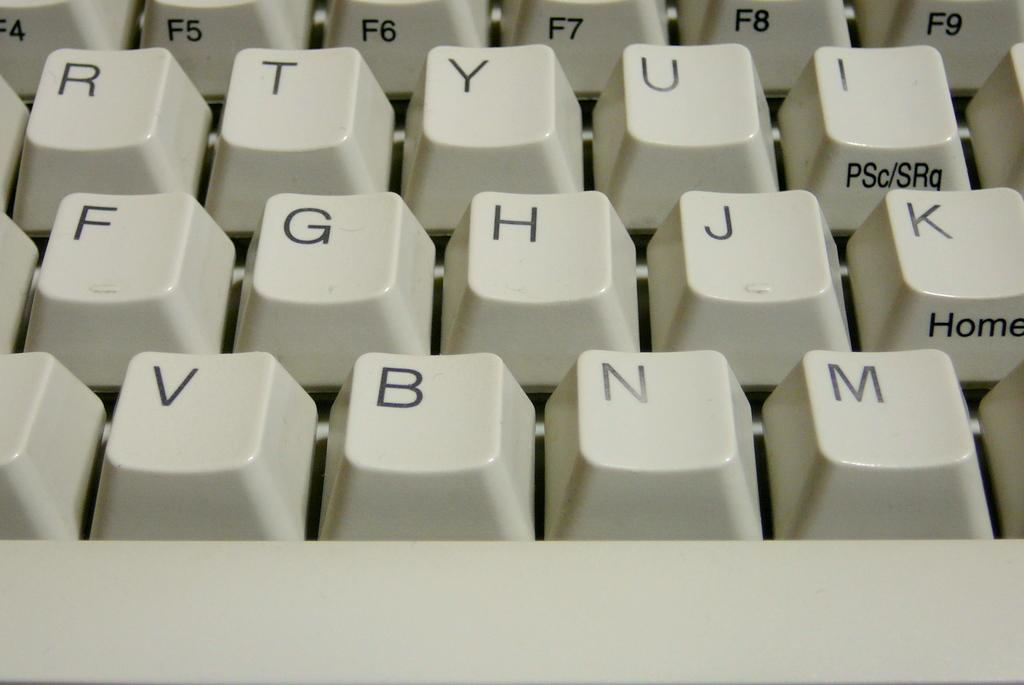<image>
Summarize the visual content of the image. A white keyboard with black letters with the word home under the K key. 